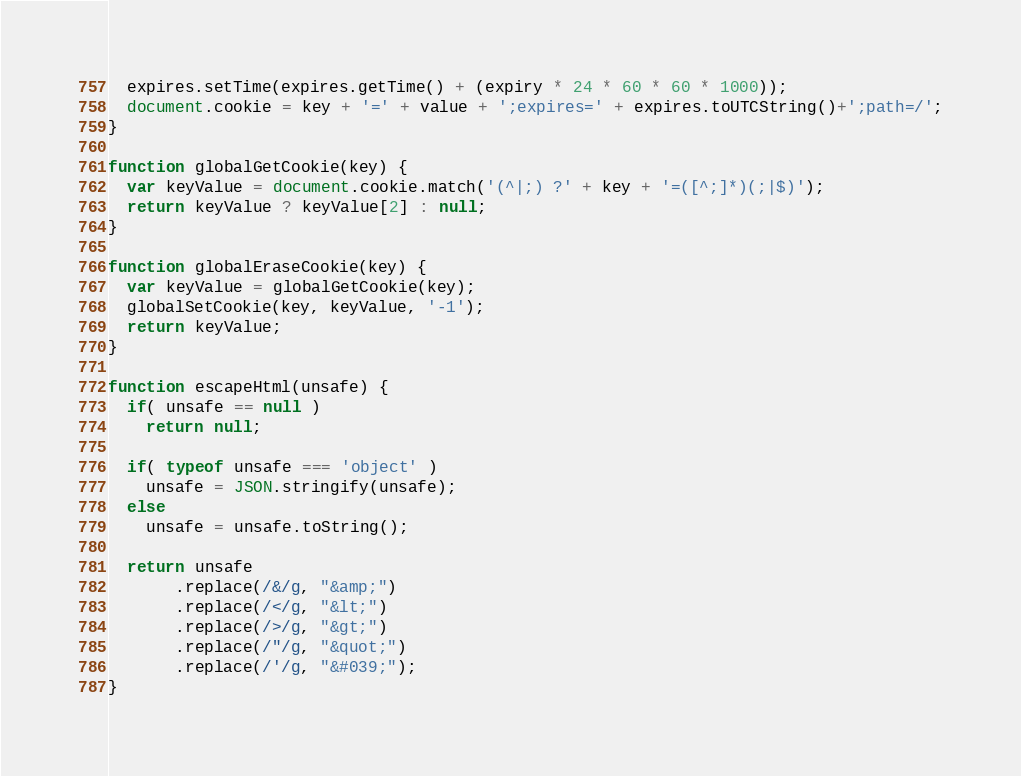<code> <loc_0><loc_0><loc_500><loc_500><_JavaScript_>  expires.setTime(expires.getTime() + (expiry * 24 * 60 * 60 * 1000));
  document.cookie = key + '=' + value + ';expires=' + expires.toUTCString()+';path=/';
}

function globalGetCookie(key) {
  var keyValue = document.cookie.match('(^|;) ?' + key + '=([^;]*)(;|$)');
  return keyValue ? keyValue[2] : null;
}

function globalEraseCookie(key) {
  var keyValue = globalGetCookie(key);
  globalSetCookie(key, keyValue, '-1');
  return keyValue;
}

function escapeHtml(unsafe) {
  if( unsafe == null )
    return null;

  if( typeof unsafe === 'object' )
    unsafe = JSON.stringify(unsafe);
  else
    unsafe = unsafe.toString();

  return unsafe
       .replace(/&/g, "&amp;")
       .replace(/</g, "&lt;")
       .replace(/>/g, "&gt;")
       .replace(/"/g, "&quot;")
       .replace(/'/g, "&#039;");
}
</code> 